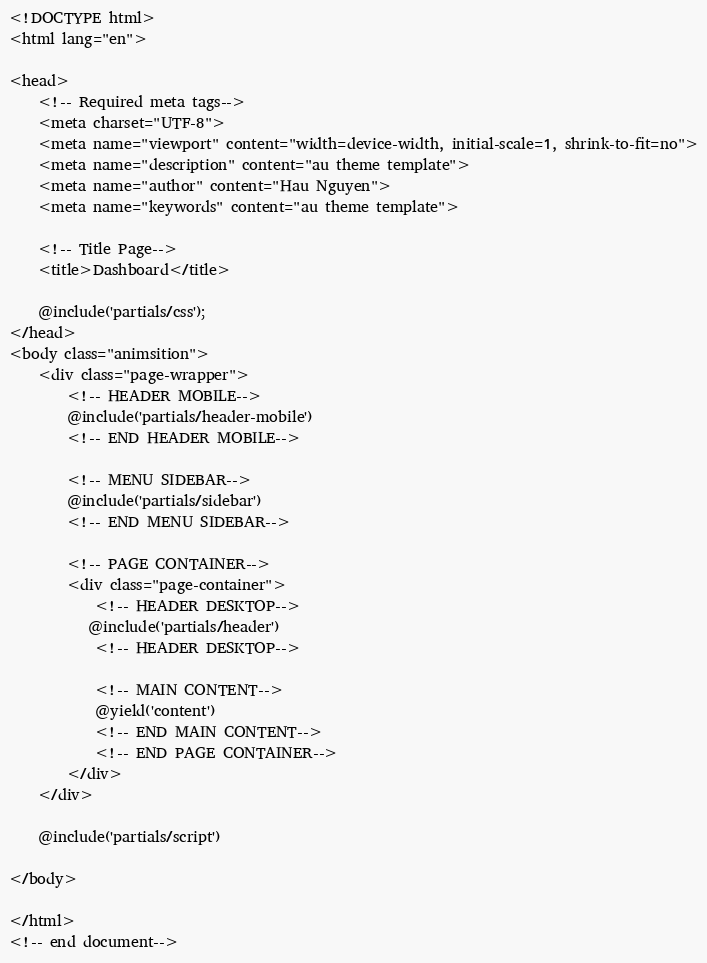<code> <loc_0><loc_0><loc_500><loc_500><_PHP_><!DOCTYPE html>
<html lang="en">

<head>
    <!-- Required meta tags-->
    <meta charset="UTF-8">
    <meta name="viewport" content="width=device-width, initial-scale=1, shrink-to-fit=no">
    <meta name="description" content="au theme template">
    <meta name="author" content="Hau Nguyen">
    <meta name="keywords" content="au theme template">

    <!-- Title Page-->
    <title>Dashboard</title>

    @include('partials/css');
</head>
<body class="animsition">
    <div class="page-wrapper">
        <!-- HEADER MOBILE-->
        @include('partials/header-mobile')
        <!-- END HEADER MOBILE-->
        
        <!-- MENU SIDEBAR-->
        @include('partials/sidebar')
        <!-- END MENU SIDEBAR-->

        <!-- PAGE CONTAINER-->
        <div class="page-container">
            <!-- HEADER DESKTOP-->
           @include('partials/header')
            <!-- HEADER DESKTOP-->

            <!-- MAIN CONTENT-->
            @yield('content')
            <!-- END MAIN CONTENT-->
            <!-- END PAGE CONTAINER-->
        </div>
    </div>

    @include('partials/script')

</body>

</html>
<!-- end document-->
</code> 